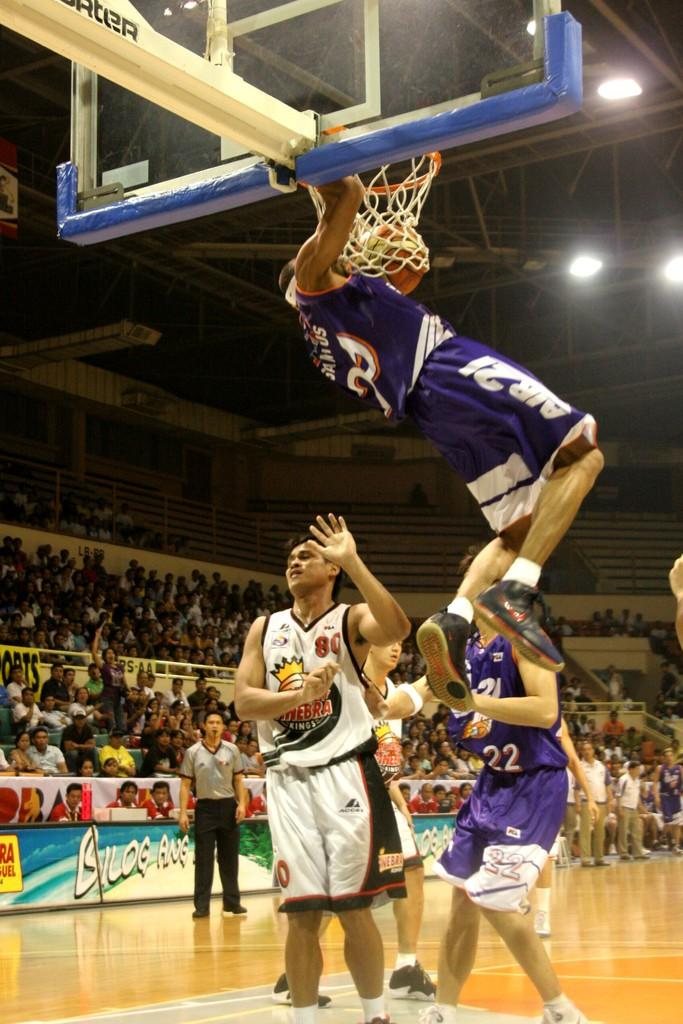<image>
Provide a brief description of the given image. Man wearing number 80 getting dunked on by a player in purple. 